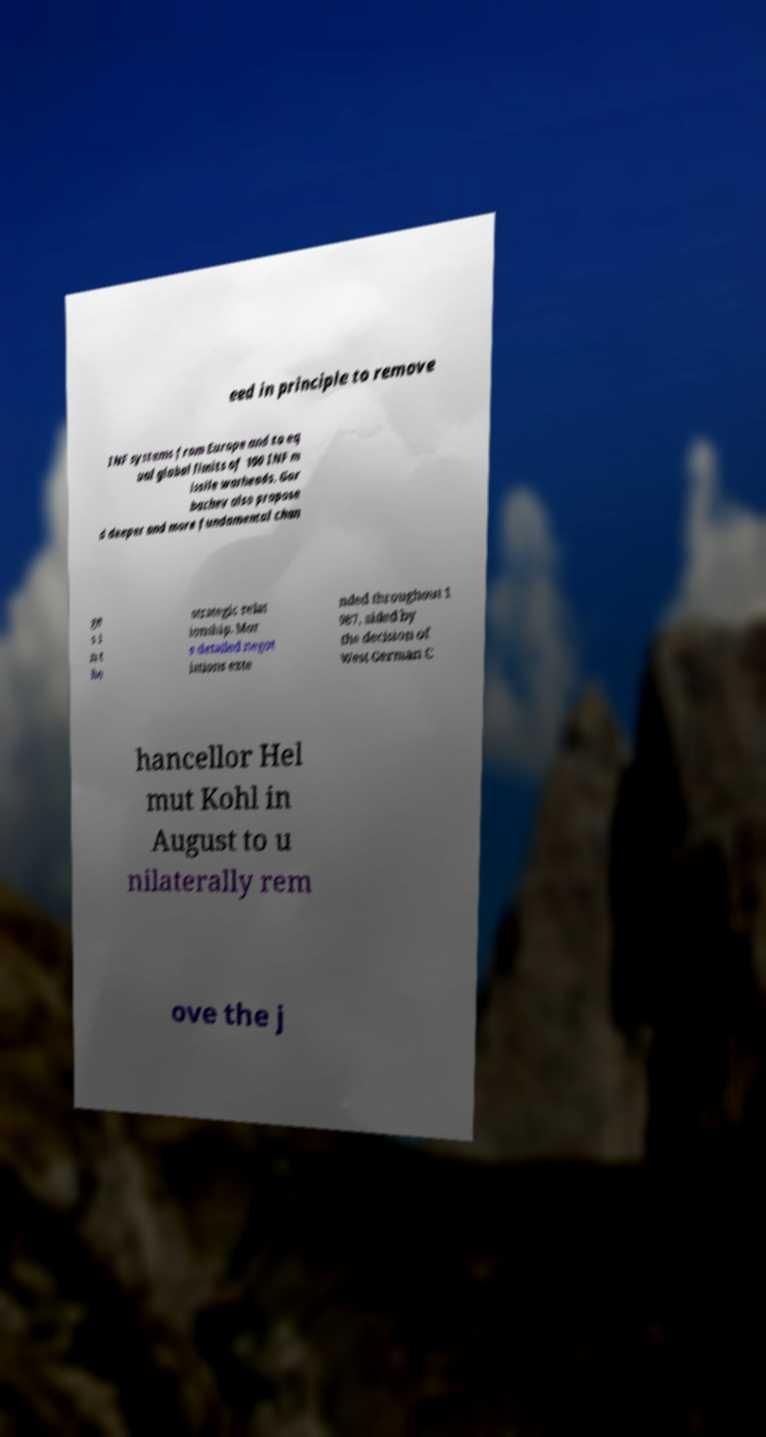There's text embedded in this image that I need extracted. Can you transcribe it verbatim? eed in principle to remove INF systems from Europe and to eq ual global limits of 100 INF m issile warheads. Gor bachev also propose d deeper and more fundamental chan ge s i n t he strategic relat ionship. Mor e detailed negot iations exte nded throughout 1 987, aided by the decision of West German C hancellor Hel mut Kohl in August to u nilaterally rem ove the j 